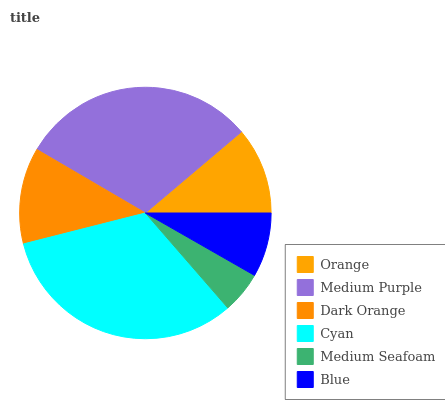Is Medium Seafoam the minimum?
Answer yes or no. Yes. Is Cyan the maximum?
Answer yes or no. Yes. Is Medium Purple the minimum?
Answer yes or no. No. Is Medium Purple the maximum?
Answer yes or no. No. Is Medium Purple greater than Orange?
Answer yes or no. Yes. Is Orange less than Medium Purple?
Answer yes or no. Yes. Is Orange greater than Medium Purple?
Answer yes or no. No. Is Medium Purple less than Orange?
Answer yes or no. No. Is Dark Orange the high median?
Answer yes or no. Yes. Is Orange the low median?
Answer yes or no. Yes. Is Blue the high median?
Answer yes or no. No. Is Cyan the low median?
Answer yes or no. No. 